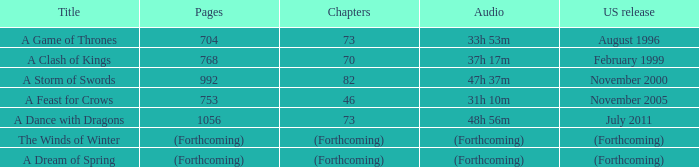How many pages does a dream of spring have? (Forthcoming). 